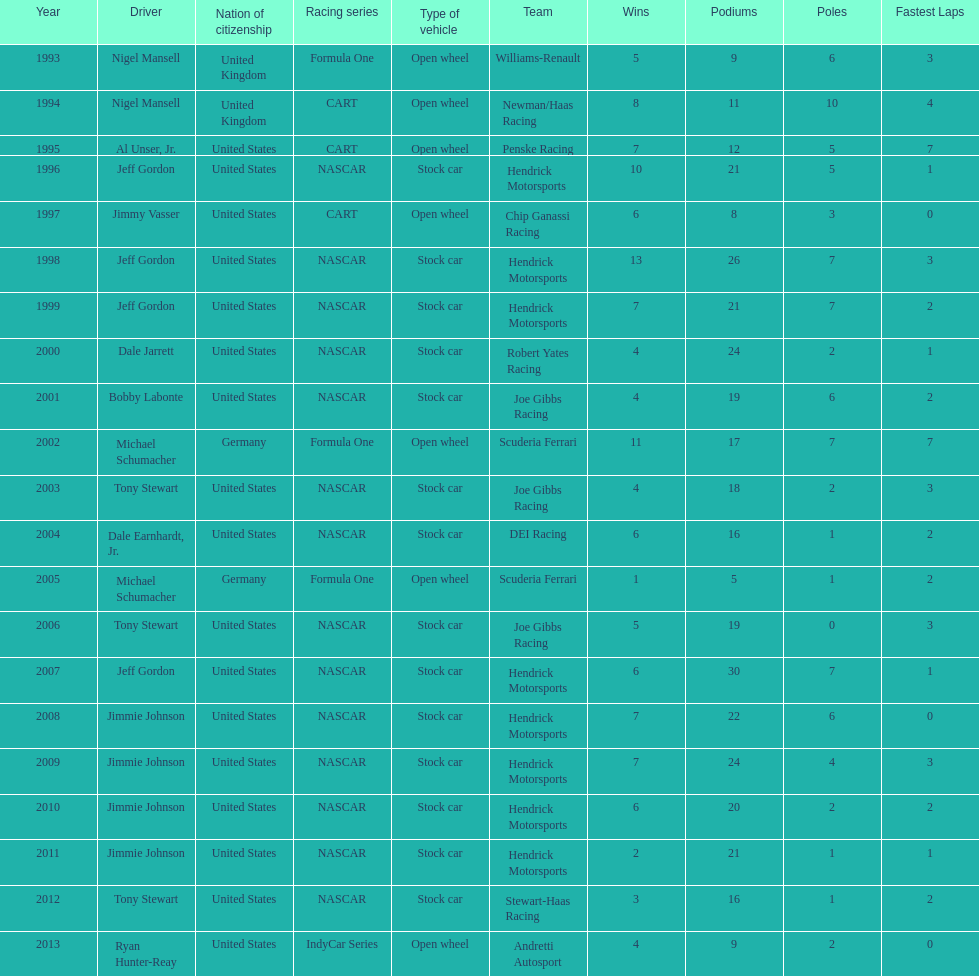Does the united states have more nation of citzenship then united kingdom? Yes. 